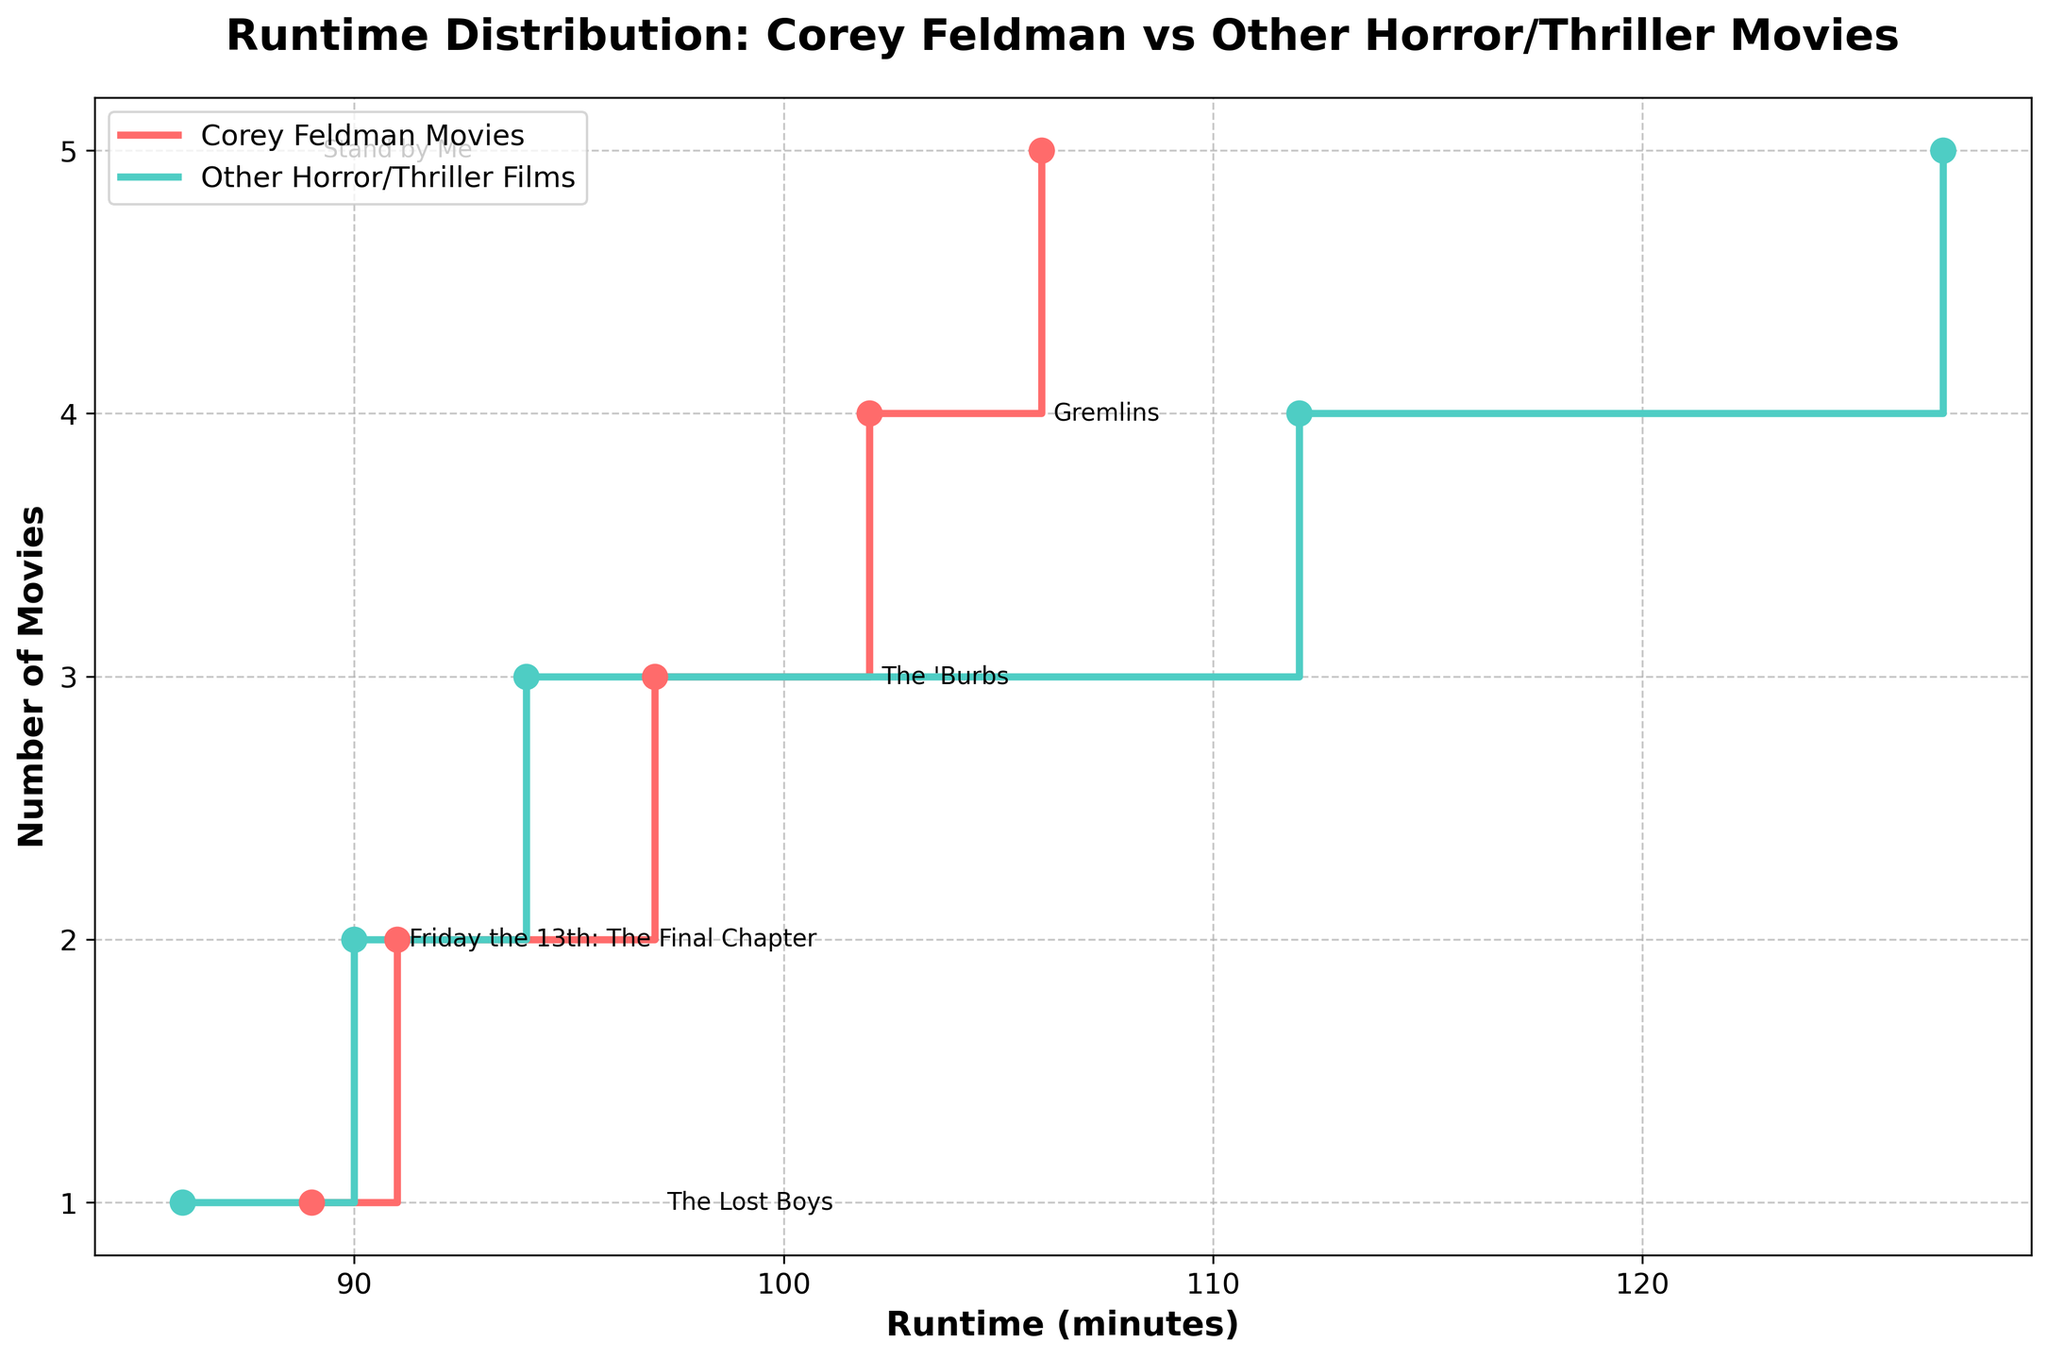What is the title of the plot? The title is displayed at the top of the plot and reads: "Runtime Distribution: Corey Feldman vs Other Horror/Thriller Movies".
Answer: Runtime Distribution: Corey Feldman vs Other Horror/Thriller Movies How many Corey Feldman movies are plotted? The Corey Feldman movies are represented by the red steps and dots. Counting them shows there are 5 movies listed.
Answer: 5 Which Corey Feldman movie has the longest runtime? Finding the highest runtime on the red step plot and looking at its annotation reveals that "Gremlins" has the longest runtime of 106 minutes.
Answer: Gremlins What is the shortest runtime among the Horror/Thriller films? Checking the lowest part of the teal step plot reveals that "Paranormal Activity" has the shortest runtime of 86 minutes.
Answer: Paranormal Activity What is the average runtime of the Corey Feldman movies? Adding the runtimes of Corey Feldman movies: 97 + 91 + 102 + 106 + 89 = 485. Dividing by the number of Corey Feldman movies (5) gives 485/5 = 97.
Answer: 97 Which group has more movies with runtimes above 100 minutes, Corey Feldman or other Horror/Thriller films? Checking both step plots, Corey Feldman movies have 2 (The 'Burbs and Gremlins) and Horror/Thriller films have 2 (Hereditary and The Conjuring). Both have 2 movies with runtimes above 100 minutes.
Answer: Both What is the difference in runtime between the longest Horror/Thriller film and the shortest Corey Feldman movie? The longest Horror/Thriller film is "Hereditary" at 127 minutes, and the shortest Corey Feldman movie is "Stand by Me" at 89 minutes. The difference is 127 - 89 = 38.
Answer: 38 Which Corey Feldman movie's runtime is closest to the average runtime of all Horror/Thriller films? Average runtime of Horror/Thriller films is (86 + 94 + 127 + 112 + 90) / 5 = 101.8. Closest Corey Feldman movie to this value is "The 'Burbs" at 102 minutes.
Answer: The 'Burbs How many movies have runtimes between 90 and 100 minutes? Checking both step plots and counting the movies within that range shows 2 Corey Feldman movies and 2 Horror/Thriller movies, total of 4.
Answer: 4 Which group has a movie with the most annotations? Both step plots have one annotation per movie, so they are equal in this regard.
Answer: Both 